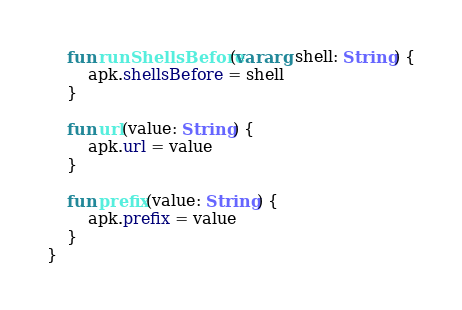<code> <loc_0><loc_0><loc_500><loc_500><_Kotlin_>
    fun runShellsBefore(vararg shell: String) {
        apk.shellsBefore = shell
    }

    fun url(value: String) {
        apk.url = value
    }

    fun prefix(value: String) {
        apk.prefix = value
    }
}
</code> 